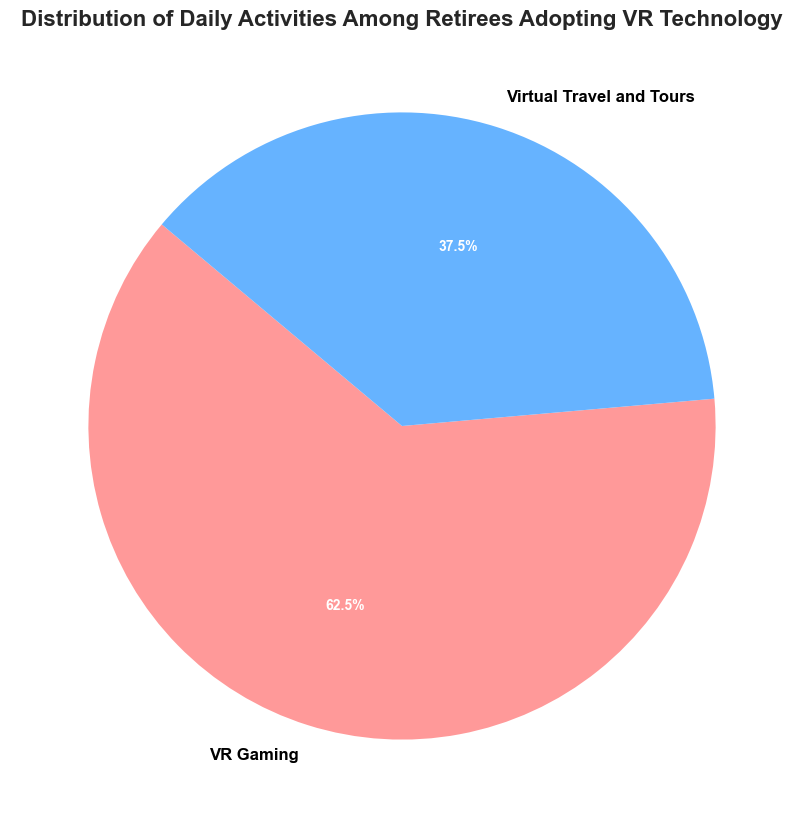What percentage of daily activities are spent on VR Gaming? VR Gaming occupies 25% of the daily activities among retirees adopting VR technology, as shown on the pie chart.
Answer: 25% Which activity is represented by the larger section of the pie chart? The pie chart has a more considerable section labeled "VR Gaming," indicating it occupies a larger percentage than any other activity.
Answer: VR Gaming What is the total percentage of activities accounted for by Virtual Travel and Tours and VR Gaming combined? VR Gaming accounts for 25%, and Virtual Travel and Tours account for 15%. Summing these, 25% + 15% = 40%.
Answer: 40% If the percentage of retirees spend on Virtual Travel and Tours increased by 10%, what would the new total percentage be for both activities combined? If Virtual Travel and Tours increased by 10%, its new percentage would be 15% + 10% = 25%. Combining with VR Gaming’s 25%, the total is 25% + 25% = 50%.
Answer: 50% How does the proportion of time spent on VR Gaming compare to Virtual Travel and Tours? VR Gaming takes up 25% while Virtual Travel and Tours take up 15%, so VR Gaming's proportion is greater.
Answer: VR Gaming is greater What color represents VR Gaming in the pie chart? The pie chart uses distinct colors for each segment. The section labeled "VR Gaming" is colored red.
Answer: Red What is the difference in the percentage of time spent between VR Gaming and Virtual Travel and Tours? VR Gaming accounts for 25%, and Virtual Travel and Tours account for 15%. The difference is 25% - 15% = 10%.
Answer: 10% Which activity is depicted in blue on the pie chart? The pie chart uses blue for one of the segments which is labeled as "Virtual Travel and Tours."
Answer: Virtual Travel and Tours What percentage of time is not accounted for by the activities shown (assuming there are other activities)? The shown activities cover 25% (VR Gaming) + 15% (Virtual Travel and Tours) = 40%, so 100% - 40% = 60% is not accounted for by these activities.
Answer: 60% If you wanted to equally divide the time spent on both activities, how much percentage should each activity ideally receive? Equally dividing the total percentage of 40% by two activities, each should receive 40% / 2 = 20%.
Answer: 20% 